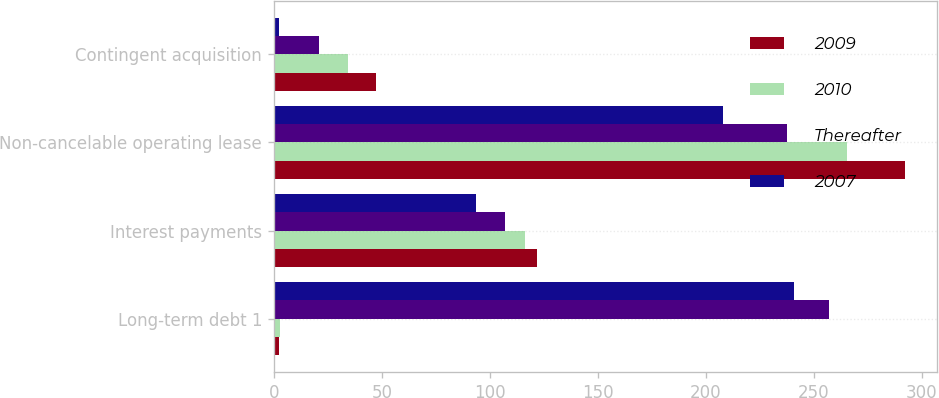Convert chart. <chart><loc_0><loc_0><loc_500><loc_500><stacked_bar_chart><ecel><fcel>Long-term debt 1<fcel>Interest payments<fcel>Non-cancelable operating lease<fcel>Contingent acquisition<nl><fcel>2009<fcel>2.6<fcel>122<fcel>292.3<fcel>47.2<nl><fcel>2010<fcel>2.8<fcel>116.1<fcel>265.2<fcel>34.2<nl><fcel>Thereafter<fcel>257<fcel>107.1<fcel>237.4<fcel>20.8<nl><fcel>2007<fcel>240.9<fcel>93.6<fcel>207.9<fcel>2.5<nl></chart> 